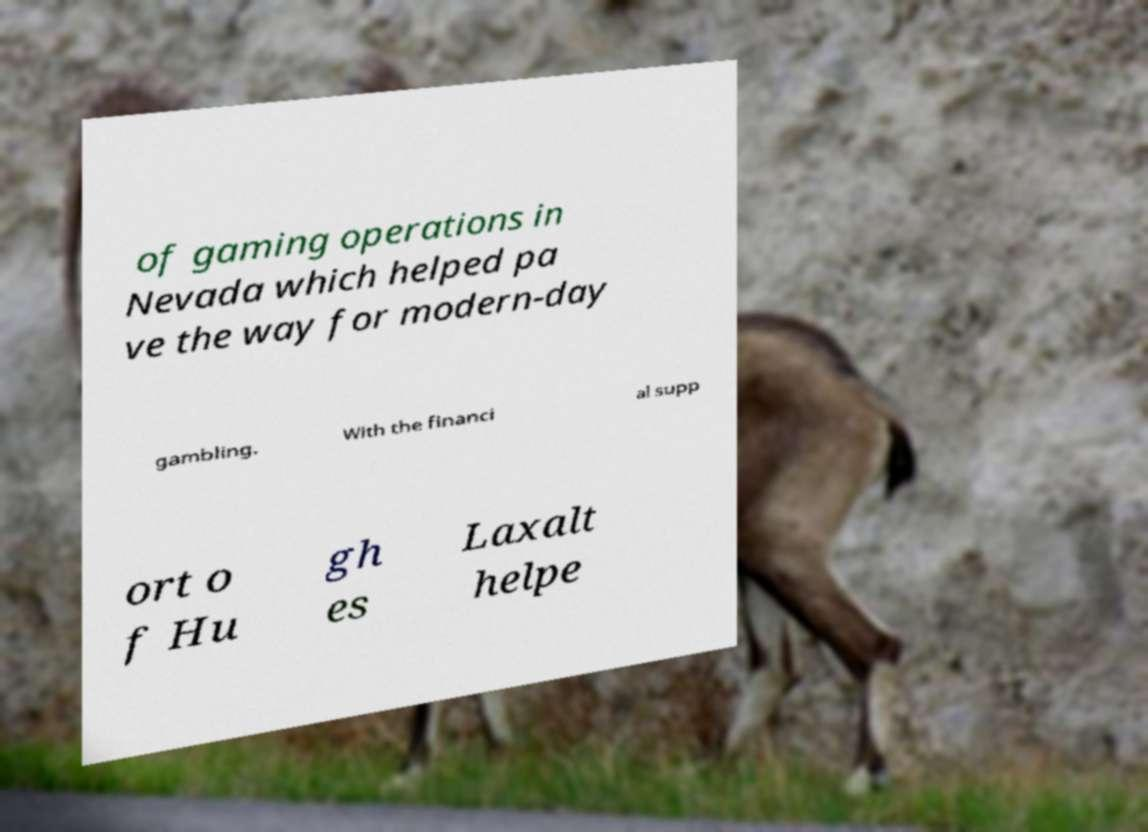Please read and relay the text visible in this image. What does it say? of gaming operations in Nevada which helped pa ve the way for modern-day gambling. With the financi al supp ort o f Hu gh es Laxalt helpe 